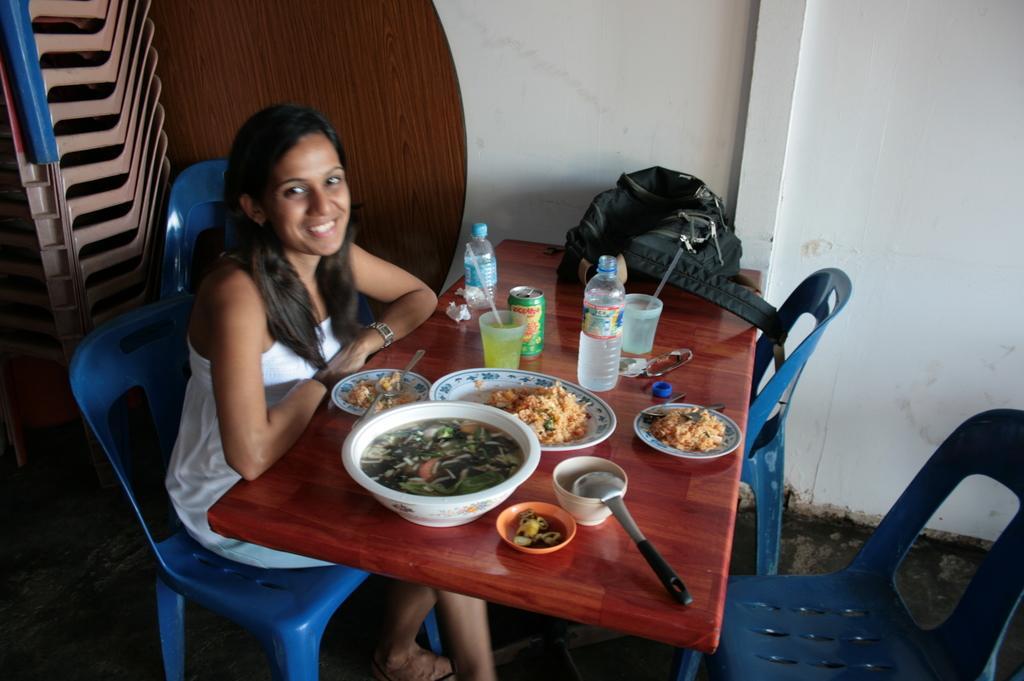How would you summarize this image in a sentence or two? In this picture there is a woman sitting on a chair and smiling and we can see bottles, plates, bowls, food, tin, spoon, bag and objects on the table. We can see chairs, wooden object, wall and floor. 